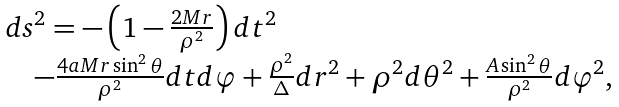<formula> <loc_0><loc_0><loc_500><loc_500>\begin{array} { l } d s ^ { 2 } = - \left ( { 1 - \frac { 2 M r } { \rho ^ { 2 } } } \right ) d t ^ { 2 } \\ \quad - \frac { 4 a M r \sin ^ { 2 } \theta } { \rho ^ { 2 } } d t d \varphi + \frac { \rho ^ { 2 } } { \Delta } d r ^ { 2 } + \rho ^ { 2 } d \theta ^ { 2 } + \frac { A \sin ^ { 2 } \theta } { \rho ^ { 2 } } d \varphi ^ { 2 } , \end{array}</formula> 